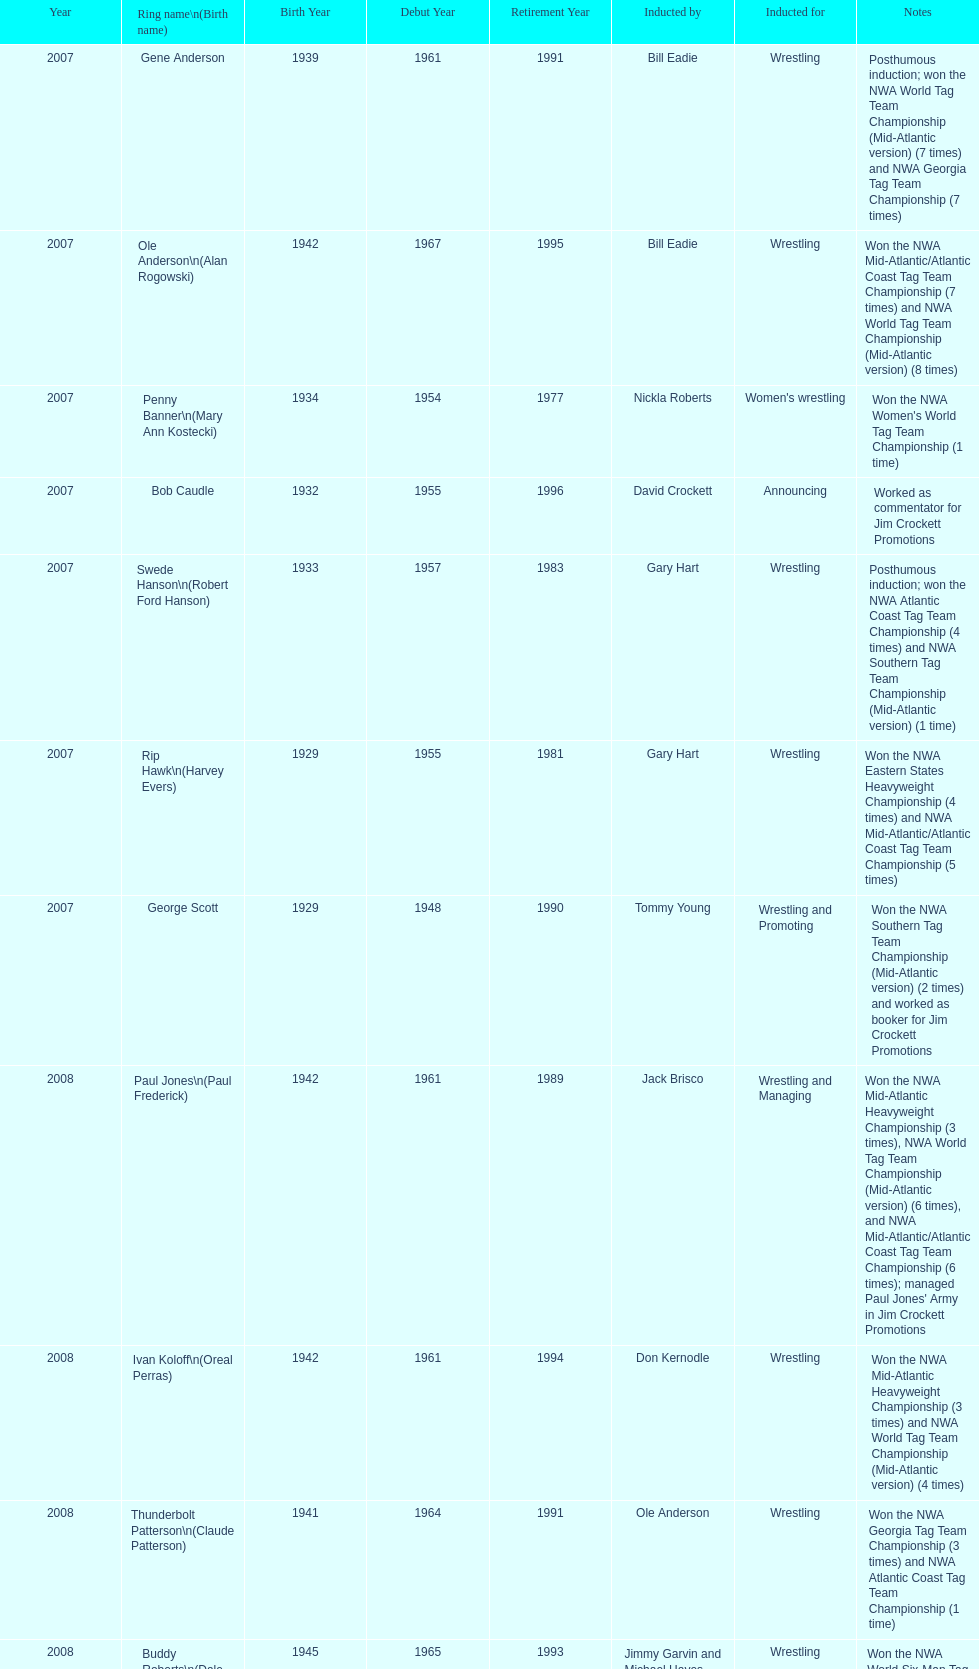Who was inducted after royal? Lance Russell. 